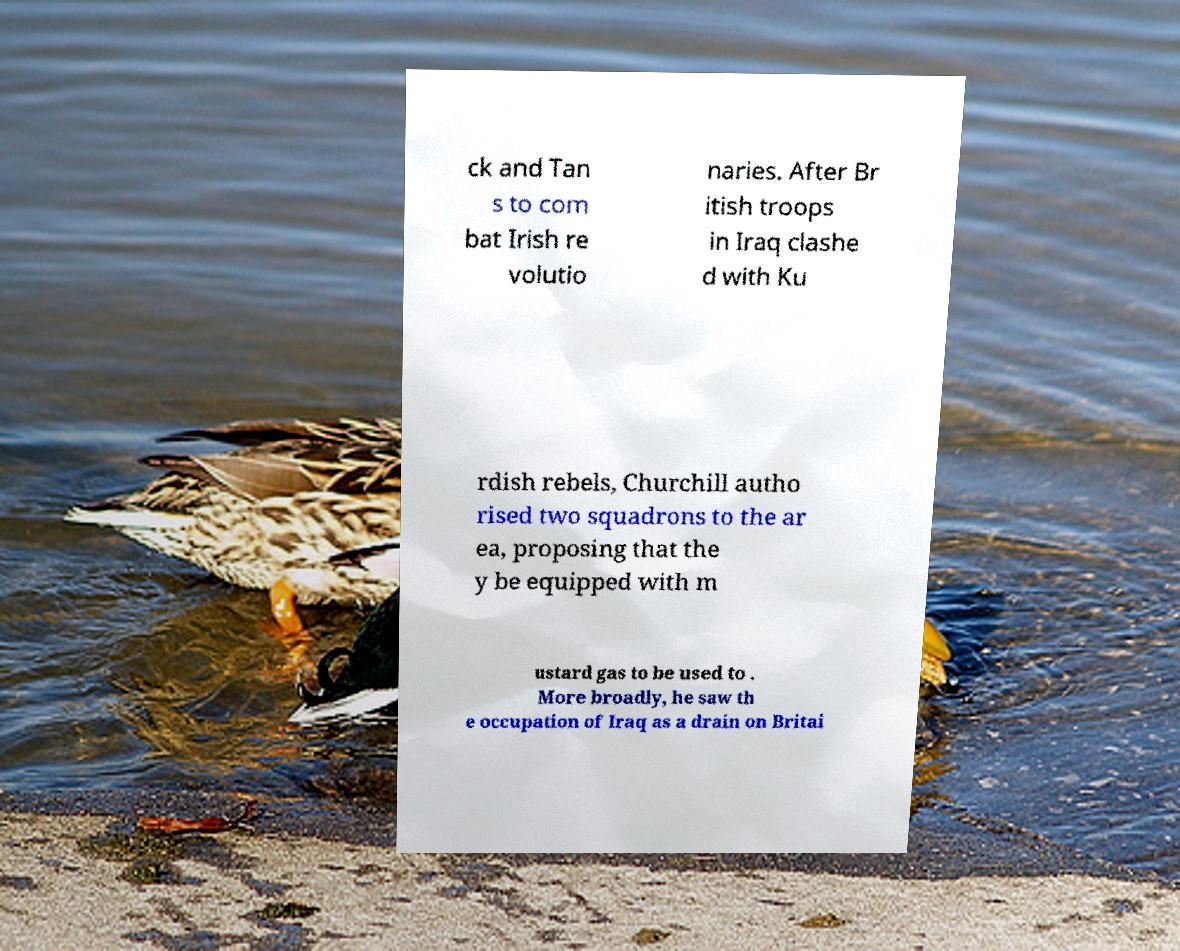Can you accurately transcribe the text from the provided image for me? ck and Tan s to com bat Irish re volutio naries. After Br itish troops in Iraq clashe d with Ku rdish rebels, Churchill autho rised two squadrons to the ar ea, proposing that the y be equipped with m ustard gas to be used to . More broadly, he saw th e occupation of Iraq as a drain on Britai 